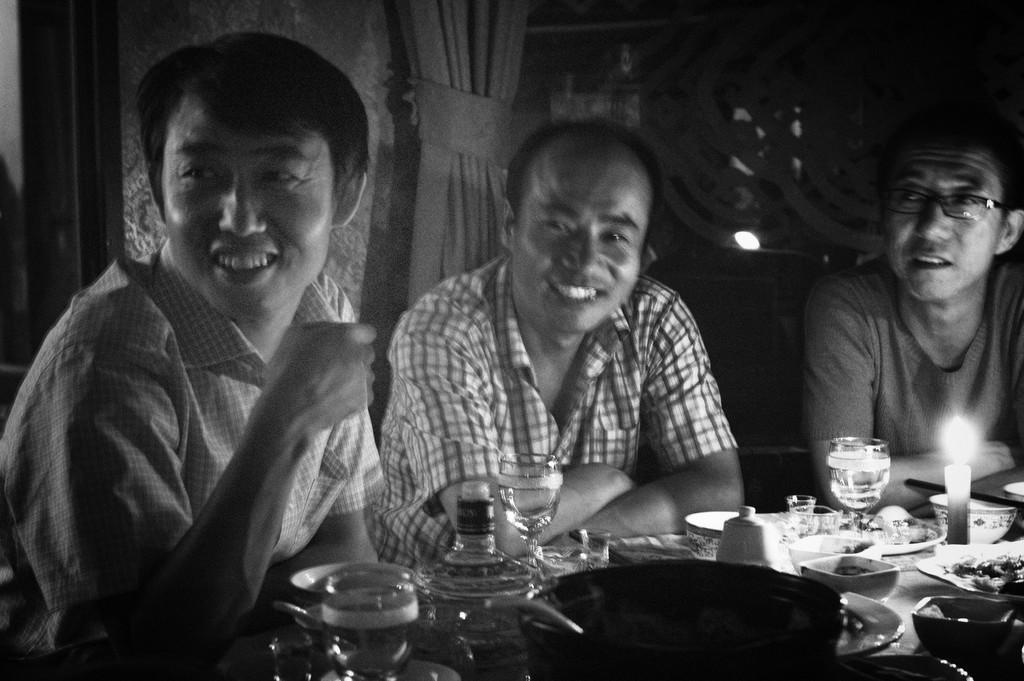How many people are sitting at the table in the image? There are three people sitting at the table in the image. What is on the table with the people? Eatables are placed on the table. Can you describe any other elements in the image? There is a curtain visible in the image. What type of pizzas are the donkeys eating in the image? There are no donkeys or pizzas present in the image. 